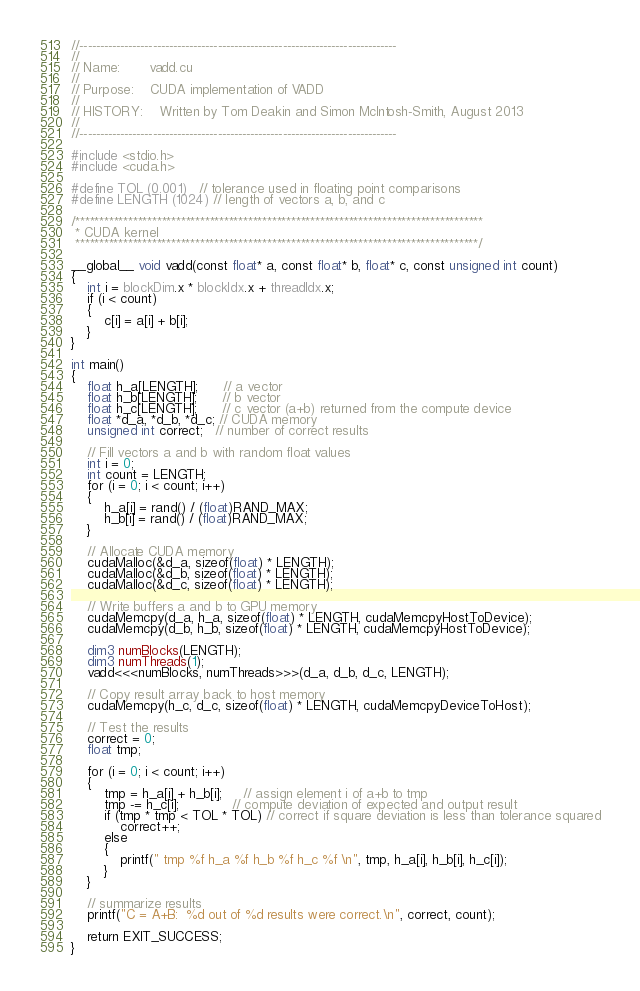Convert code to text. <code><loc_0><loc_0><loc_500><loc_500><_Cuda_>//------------------------------------------------------------------------------
//
// Name:       vadd.cu
//
// Purpose:    CUDA implementation of VADD
//
// HISTORY:    Written by Tom Deakin and Simon McIntosh-Smith, August 2013
//
//------------------------------------------------------------------------------

#include <stdio.h>
#include <cuda.h>

#define TOL (0.001)   // tolerance used in floating point comparisons
#define LENGTH (1024) // length of vectors a, b, and c

/*************************************************************************************
 * CUDA kernel
 ************************************************************************************/

__global__ void vadd(const float* a, const float* b, float* c, const unsigned int count)
{
    int i = blockDim.x * blockIdx.x + threadIdx.x;
    if (i < count)
    {
        c[i] = a[i] + b[i];
    }
}

int main()
{
    float h_a[LENGTH];      // a vector
    float h_b[LENGTH];      // b vector
    float h_c[LENGTH];      // c vector (a+b) returned from the compute device
    float *d_a, *d_b, *d_c; // CUDA memory
    unsigned int correct;   // number of correct results

    // Fill vectors a and b with random float values
    int i = 0;
    int count = LENGTH;
    for (i = 0; i < count; i++)
    {
        h_a[i] = rand() / (float)RAND_MAX;
        h_b[i] = rand() / (float)RAND_MAX;
    }

    // Allocate CUDA memory
    cudaMalloc(&d_a, sizeof(float) * LENGTH);
    cudaMalloc(&d_b, sizeof(float) * LENGTH);
    cudaMalloc(&d_c, sizeof(float) * LENGTH);

    // Write buffers a and b to GPU memory
    cudaMemcpy(d_a, h_a, sizeof(float) * LENGTH, cudaMemcpyHostToDevice);
    cudaMemcpy(d_b, h_b, sizeof(float) * LENGTH, cudaMemcpyHostToDevice);

    dim3 numBlocks(LENGTH);
    dim3 numThreads(1);
    vadd<<<numBlocks, numThreads>>>(d_a, d_b, d_c, LENGTH);

    // Copy result array back to host memory
    cudaMemcpy(h_c, d_c, sizeof(float) * LENGTH, cudaMemcpyDeviceToHost);

    // Test the results
    correct = 0;
    float tmp;

    for (i = 0; i < count; i++)
    {
        tmp = h_a[i] + h_b[i];     // assign element i of a+b to tmp
        tmp -= h_c[i];             // compute deviation of expected and output result
        if (tmp * tmp < TOL * TOL) // correct if square deviation is less than tolerance squared
            correct++;
        else
        {
            printf(" tmp %f h_a %f h_b %f h_c %f \n", tmp, h_a[i], h_b[i], h_c[i]);
        }
    }

    // summarize results
    printf("C = A+B:  %d out of %d results were correct.\n", correct, count);

    return EXIT_SUCCESS;
}
</code> 